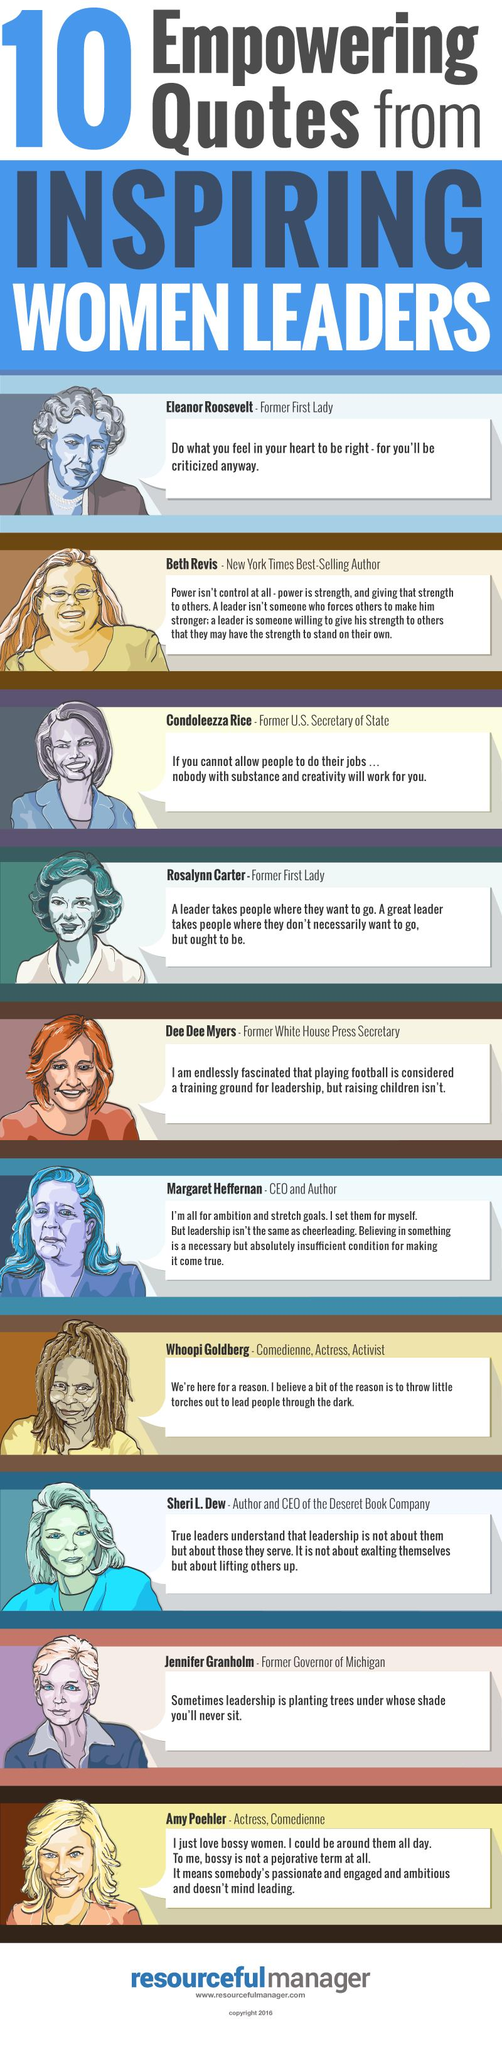Highlight a few significant elements in this photo. Two renowned women comedians, Whoopie Goldberg and Amy Poehler, are recognized as leaders in their respective fields. The two former first ladies mentioned in the list of women leaders are Eleanor Roosevelt and Rosalynn Carter. 